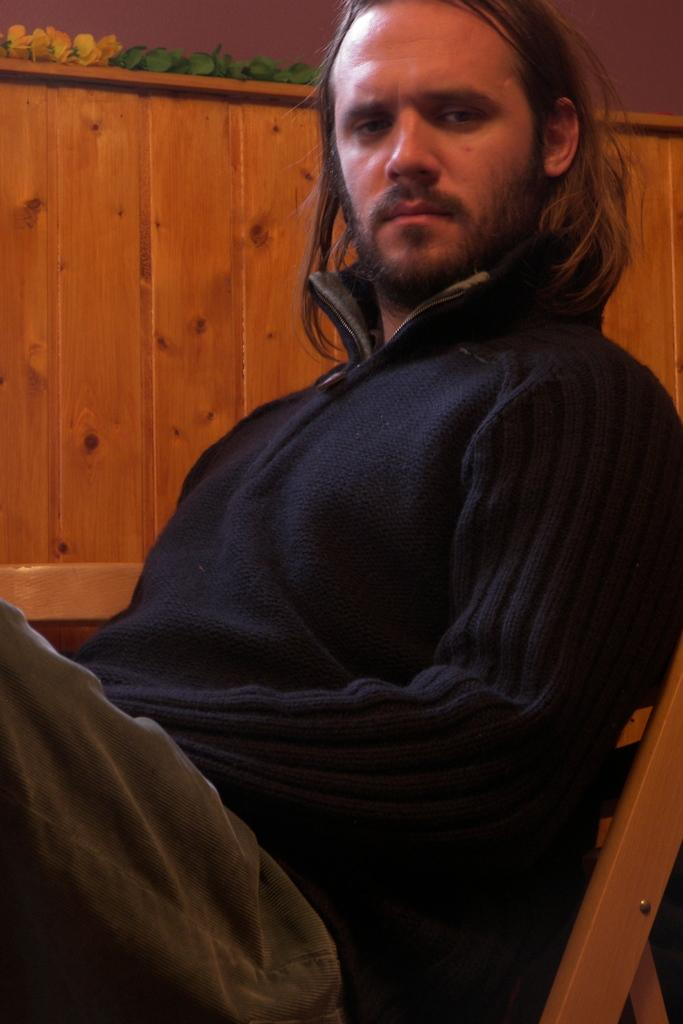What is the man in the image doing? The man is sitting on a chair in the image. What can be seen behind the man in the image? There is a wall visible in the image. What decorative items are present on a table in the image? There are decorative flowers on a table in the image. What type of force is being applied to the flowers on the table in the image? There is no indication of any force being applied to the flowers in the image; they are simply decorative items on a table. 